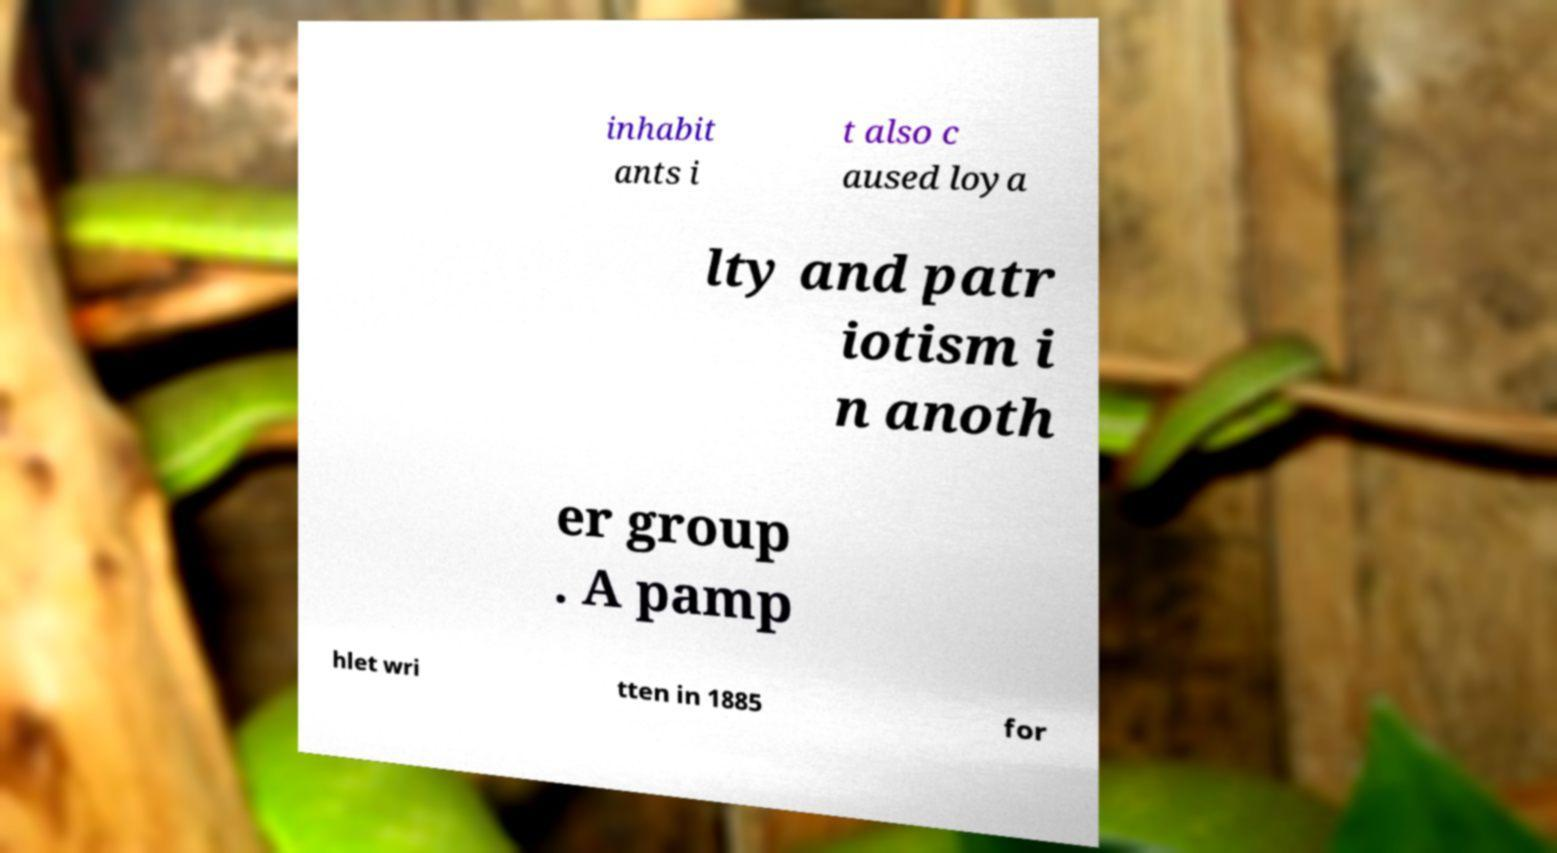Please read and relay the text visible in this image. What does it say? inhabit ants i t also c aused loya lty and patr iotism i n anoth er group . A pamp hlet wri tten in 1885 for 